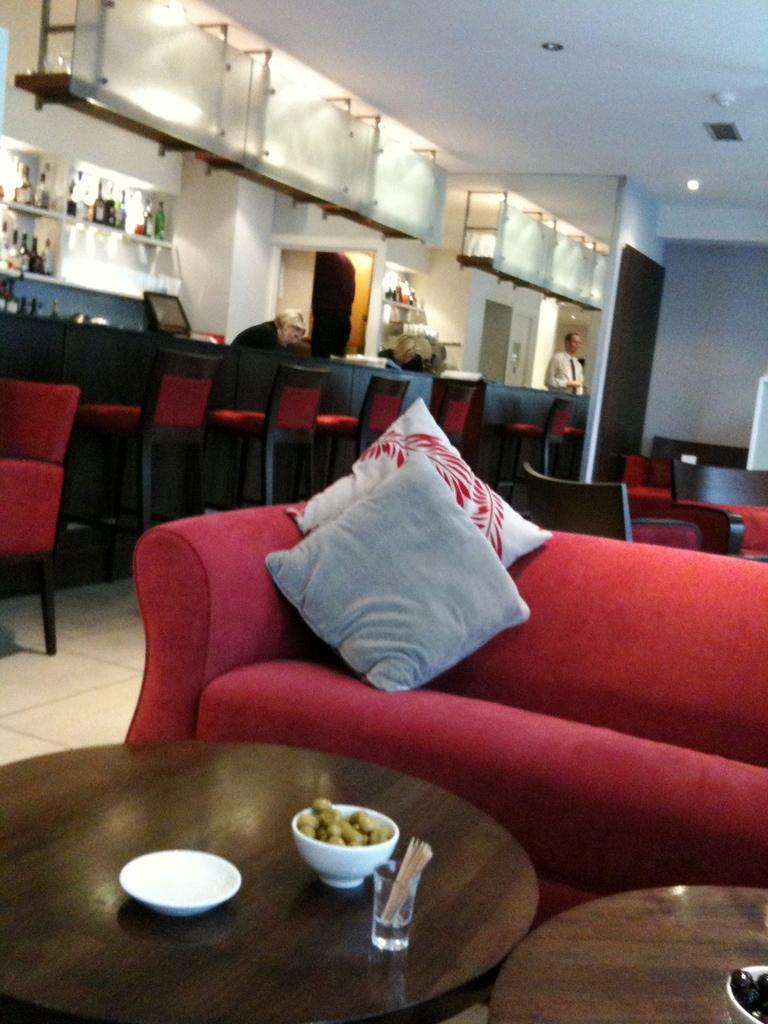In one or two sentences, can you explain what this image depicts? In this image I see number of chairs and a couch over here on which there are 2 cushions, I can also see there are 2 tables on which there is a plate, 2 bowls food in it and a glass. In the background I see 2 persons, few bottles on the rack and a screen over here. 